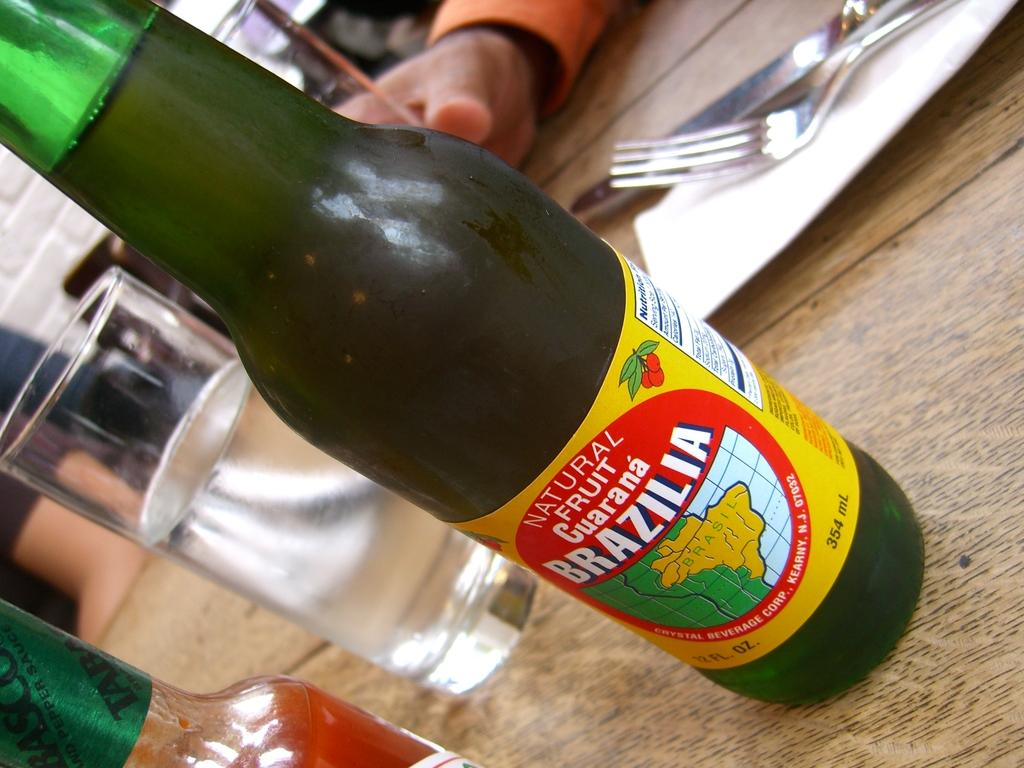What piece of furniture is present in the image? There is a table in the image. What object can be seen on the table? There is a bottle on the table. What else is on the table besides the bottle? There are glasses and spoons on the table. Whose hand is visible in the image? A person's hand is visible in the image. What type of prose is being recited by the person in the image? There is no indication in the image that someone is reciting prose, and therefore no such activity can be observed. 